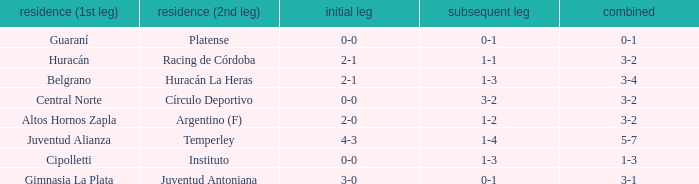Who played at home for the 2nd leg with a score of 1-2? Argentino (F). 